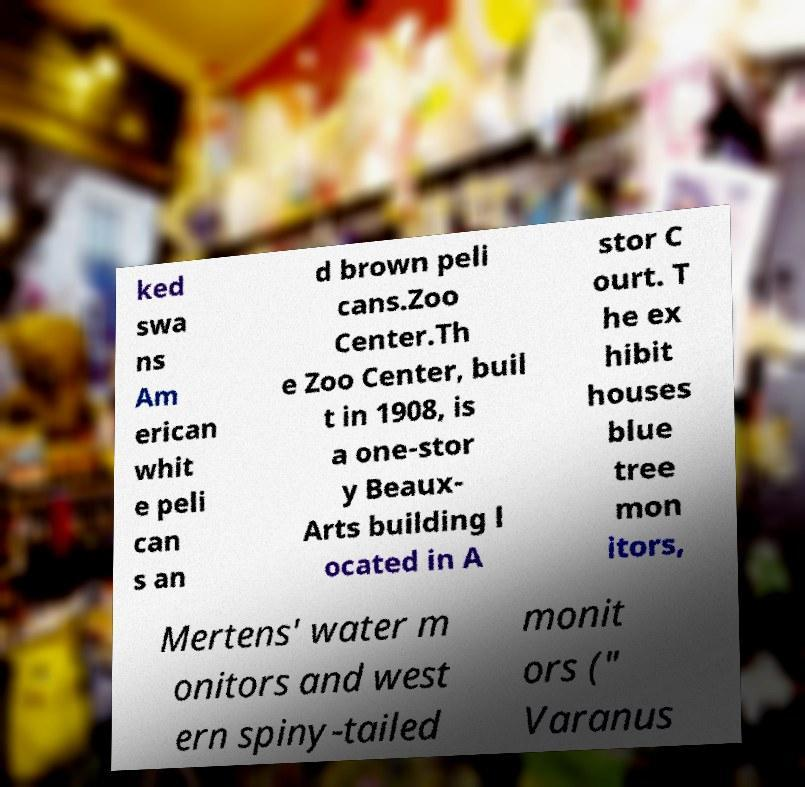Could you assist in decoding the text presented in this image and type it out clearly? ked swa ns Am erican whit e peli can s an d brown peli cans.Zoo Center.Th e Zoo Center, buil t in 1908, is a one-stor y Beaux- Arts building l ocated in A stor C ourt. T he ex hibit houses blue tree mon itors, Mertens' water m onitors and west ern spiny-tailed monit ors (" Varanus 